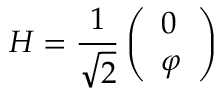<formula> <loc_0><loc_0><loc_500><loc_500>H = \frac { 1 } { \sqrt { 2 } } \left ( \begin{array} { l } { 0 } \\ { \varphi } \end{array} \right )</formula> 